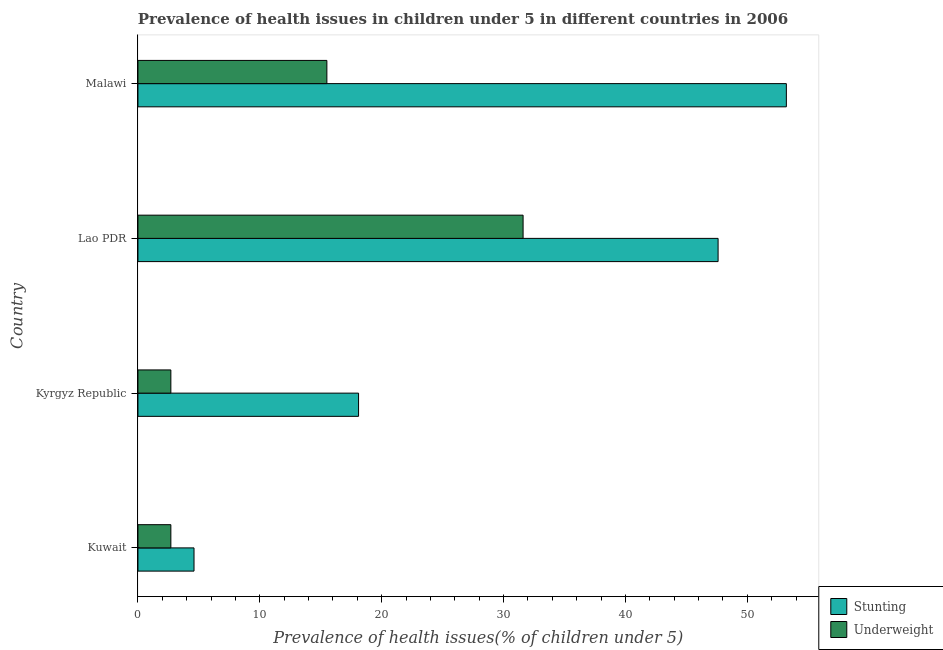How many different coloured bars are there?
Provide a short and direct response. 2. How many groups of bars are there?
Provide a succinct answer. 4. Are the number of bars per tick equal to the number of legend labels?
Make the answer very short. Yes. How many bars are there on the 3rd tick from the top?
Your answer should be very brief. 2. How many bars are there on the 3rd tick from the bottom?
Offer a very short reply. 2. What is the label of the 3rd group of bars from the top?
Provide a succinct answer. Kyrgyz Republic. Across all countries, what is the maximum percentage of stunted children?
Your response must be concise. 53.2. Across all countries, what is the minimum percentage of stunted children?
Your answer should be very brief. 4.6. In which country was the percentage of stunted children maximum?
Your answer should be compact. Malawi. In which country was the percentage of underweight children minimum?
Keep it short and to the point. Kuwait. What is the total percentage of stunted children in the graph?
Make the answer very short. 123.5. What is the difference between the percentage of underweight children in Kyrgyz Republic and that in Lao PDR?
Offer a terse response. -28.9. What is the difference between the percentage of stunted children in Kuwait and the percentage of underweight children in Lao PDR?
Your answer should be very brief. -27. What is the average percentage of stunted children per country?
Your answer should be compact. 30.88. What is the ratio of the percentage of underweight children in Kuwait to that in Lao PDR?
Make the answer very short. 0.09. Is the percentage of underweight children in Kuwait less than that in Kyrgyz Republic?
Your answer should be compact. No. What is the difference between the highest and the lowest percentage of underweight children?
Your response must be concise. 28.9. In how many countries, is the percentage of stunted children greater than the average percentage of stunted children taken over all countries?
Your response must be concise. 2. What does the 2nd bar from the top in Kyrgyz Republic represents?
Ensure brevity in your answer.  Stunting. What does the 1st bar from the bottom in Malawi represents?
Make the answer very short. Stunting. How many bars are there?
Offer a very short reply. 8. How many legend labels are there?
Give a very brief answer. 2. How are the legend labels stacked?
Ensure brevity in your answer.  Vertical. What is the title of the graph?
Provide a short and direct response. Prevalence of health issues in children under 5 in different countries in 2006. Does "Taxes on exports" appear as one of the legend labels in the graph?
Provide a succinct answer. No. What is the label or title of the X-axis?
Give a very brief answer. Prevalence of health issues(% of children under 5). What is the Prevalence of health issues(% of children under 5) of Stunting in Kuwait?
Your response must be concise. 4.6. What is the Prevalence of health issues(% of children under 5) in Underweight in Kuwait?
Keep it short and to the point. 2.7. What is the Prevalence of health issues(% of children under 5) of Stunting in Kyrgyz Republic?
Ensure brevity in your answer.  18.1. What is the Prevalence of health issues(% of children under 5) in Underweight in Kyrgyz Republic?
Ensure brevity in your answer.  2.7. What is the Prevalence of health issues(% of children under 5) of Stunting in Lao PDR?
Offer a very short reply. 47.6. What is the Prevalence of health issues(% of children under 5) of Underweight in Lao PDR?
Your answer should be compact. 31.6. What is the Prevalence of health issues(% of children under 5) of Stunting in Malawi?
Give a very brief answer. 53.2. What is the Prevalence of health issues(% of children under 5) in Underweight in Malawi?
Your answer should be very brief. 15.5. Across all countries, what is the maximum Prevalence of health issues(% of children under 5) of Stunting?
Ensure brevity in your answer.  53.2. Across all countries, what is the maximum Prevalence of health issues(% of children under 5) of Underweight?
Provide a short and direct response. 31.6. Across all countries, what is the minimum Prevalence of health issues(% of children under 5) in Stunting?
Offer a very short reply. 4.6. Across all countries, what is the minimum Prevalence of health issues(% of children under 5) in Underweight?
Give a very brief answer. 2.7. What is the total Prevalence of health issues(% of children under 5) in Stunting in the graph?
Offer a terse response. 123.5. What is the total Prevalence of health issues(% of children under 5) in Underweight in the graph?
Your answer should be very brief. 52.5. What is the difference between the Prevalence of health issues(% of children under 5) of Stunting in Kuwait and that in Lao PDR?
Offer a very short reply. -43. What is the difference between the Prevalence of health issues(% of children under 5) of Underweight in Kuwait and that in Lao PDR?
Your answer should be compact. -28.9. What is the difference between the Prevalence of health issues(% of children under 5) of Stunting in Kuwait and that in Malawi?
Keep it short and to the point. -48.6. What is the difference between the Prevalence of health issues(% of children under 5) in Underweight in Kuwait and that in Malawi?
Make the answer very short. -12.8. What is the difference between the Prevalence of health issues(% of children under 5) of Stunting in Kyrgyz Republic and that in Lao PDR?
Your answer should be very brief. -29.5. What is the difference between the Prevalence of health issues(% of children under 5) of Underweight in Kyrgyz Republic and that in Lao PDR?
Provide a succinct answer. -28.9. What is the difference between the Prevalence of health issues(% of children under 5) in Stunting in Kyrgyz Republic and that in Malawi?
Your response must be concise. -35.1. What is the difference between the Prevalence of health issues(% of children under 5) of Underweight in Kyrgyz Republic and that in Malawi?
Make the answer very short. -12.8. What is the difference between the Prevalence of health issues(% of children under 5) in Stunting in Kuwait and the Prevalence of health issues(% of children under 5) in Underweight in Kyrgyz Republic?
Provide a short and direct response. 1.9. What is the difference between the Prevalence of health issues(% of children under 5) of Stunting in Kyrgyz Republic and the Prevalence of health issues(% of children under 5) of Underweight in Lao PDR?
Your response must be concise. -13.5. What is the difference between the Prevalence of health issues(% of children under 5) in Stunting in Kyrgyz Republic and the Prevalence of health issues(% of children under 5) in Underweight in Malawi?
Make the answer very short. 2.6. What is the difference between the Prevalence of health issues(% of children under 5) in Stunting in Lao PDR and the Prevalence of health issues(% of children under 5) in Underweight in Malawi?
Your answer should be very brief. 32.1. What is the average Prevalence of health issues(% of children under 5) in Stunting per country?
Give a very brief answer. 30.88. What is the average Prevalence of health issues(% of children under 5) in Underweight per country?
Give a very brief answer. 13.12. What is the difference between the Prevalence of health issues(% of children under 5) in Stunting and Prevalence of health issues(% of children under 5) in Underweight in Lao PDR?
Offer a very short reply. 16. What is the difference between the Prevalence of health issues(% of children under 5) of Stunting and Prevalence of health issues(% of children under 5) of Underweight in Malawi?
Ensure brevity in your answer.  37.7. What is the ratio of the Prevalence of health issues(% of children under 5) of Stunting in Kuwait to that in Kyrgyz Republic?
Your answer should be compact. 0.25. What is the ratio of the Prevalence of health issues(% of children under 5) of Underweight in Kuwait to that in Kyrgyz Republic?
Offer a terse response. 1. What is the ratio of the Prevalence of health issues(% of children under 5) of Stunting in Kuwait to that in Lao PDR?
Provide a succinct answer. 0.1. What is the ratio of the Prevalence of health issues(% of children under 5) in Underweight in Kuwait to that in Lao PDR?
Provide a succinct answer. 0.09. What is the ratio of the Prevalence of health issues(% of children under 5) in Stunting in Kuwait to that in Malawi?
Your answer should be compact. 0.09. What is the ratio of the Prevalence of health issues(% of children under 5) in Underweight in Kuwait to that in Malawi?
Make the answer very short. 0.17. What is the ratio of the Prevalence of health issues(% of children under 5) in Stunting in Kyrgyz Republic to that in Lao PDR?
Offer a very short reply. 0.38. What is the ratio of the Prevalence of health issues(% of children under 5) of Underweight in Kyrgyz Republic to that in Lao PDR?
Your answer should be compact. 0.09. What is the ratio of the Prevalence of health issues(% of children under 5) of Stunting in Kyrgyz Republic to that in Malawi?
Provide a succinct answer. 0.34. What is the ratio of the Prevalence of health issues(% of children under 5) in Underweight in Kyrgyz Republic to that in Malawi?
Your answer should be very brief. 0.17. What is the ratio of the Prevalence of health issues(% of children under 5) of Stunting in Lao PDR to that in Malawi?
Your response must be concise. 0.89. What is the ratio of the Prevalence of health issues(% of children under 5) in Underweight in Lao PDR to that in Malawi?
Provide a short and direct response. 2.04. What is the difference between the highest and the lowest Prevalence of health issues(% of children under 5) of Stunting?
Offer a terse response. 48.6. What is the difference between the highest and the lowest Prevalence of health issues(% of children under 5) in Underweight?
Provide a succinct answer. 28.9. 